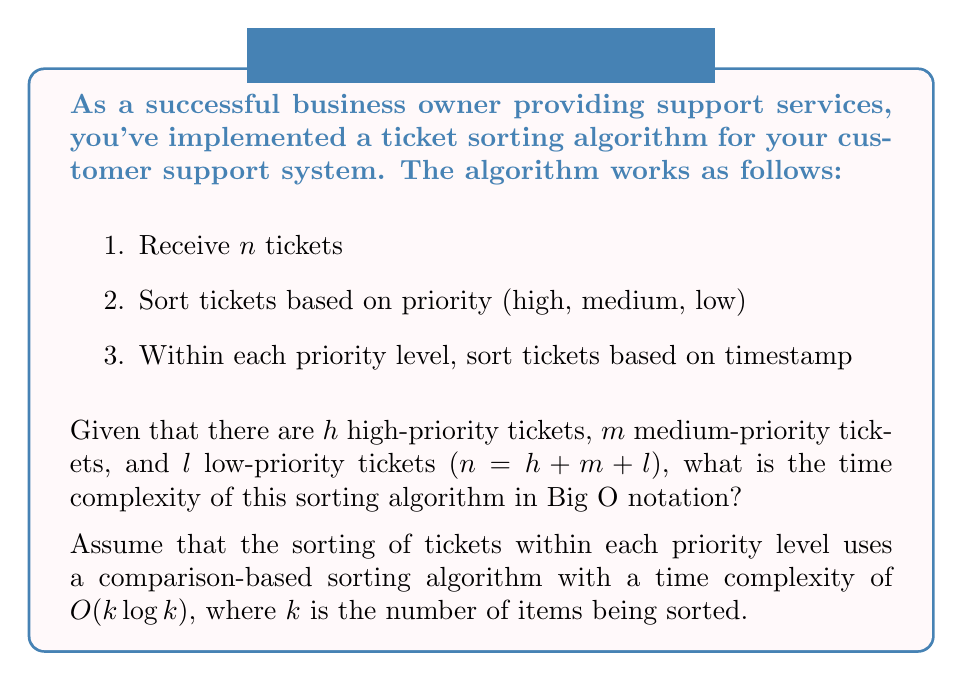Could you help me with this problem? Let's analyze the time complexity step by step:

1. Receiving $n$ tickets: $O(n)$

2. Sorting tickets based on priority:
   This can be done in a single pass through all tickets, assigning them to three separate lists. Time complexity: $O(n)$

3. Sorting within each priority level:
   - High-priority tickets: $O(h \log h)$
   - Medium-priority tickets: $O(m \log m)$
   - Low-priority tickets: $O(l \log l)$

The total time complexity is the sum of these operations:

$$O(n) + O(n) + O(h \log h) + O(m \log m) + O(l \log l)$$

Simplifying:

$$O(n) + O(h \log h) + O(m \log m) + O(l \log l)$$

Now, we need to express this in terms of $n$. The worst-case scenario occurs when all tickets are in a single priority level, e.g., all are high-priority. In this case:

$$h = n, m = 0, l = 0$$

This gives us:

$$O(n) + O(n \log n) + O(0) + O(0) = O(n \log n)$$

Since $O(n \log n)$ dominates $O(n)$, we can simplify further:

$$O(n \log n)$$

Therefore, the overall time complexity of the sorting algorithm is $O(n \log n)$.
Answer: $O(n \log n)$ 